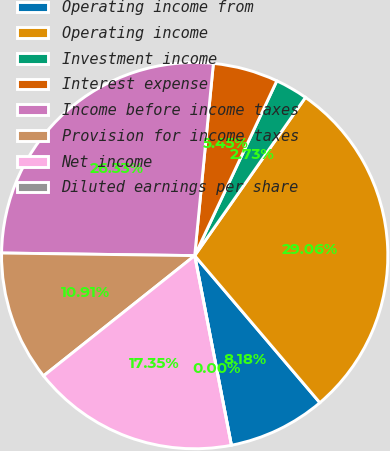Convert chart. <chart><loc_0><loc_0><loc_500><loc_500><pie_chart><fcel>Operating income from<fcel>Operating income<fcel>Investment income<fcel>Interest expense<fcel>Income before income taxes<fcel>Provision for income taxes<fcel>Net income<fcel>Diluted earnings per share<nl><fcel>8.18%<fcel>29.06%<fcel>2.73%<fcel>5.45%<fcel>26.33%<fcel>10.91%<fcel>17.35%<fcel>0.0%<nl></chart> 